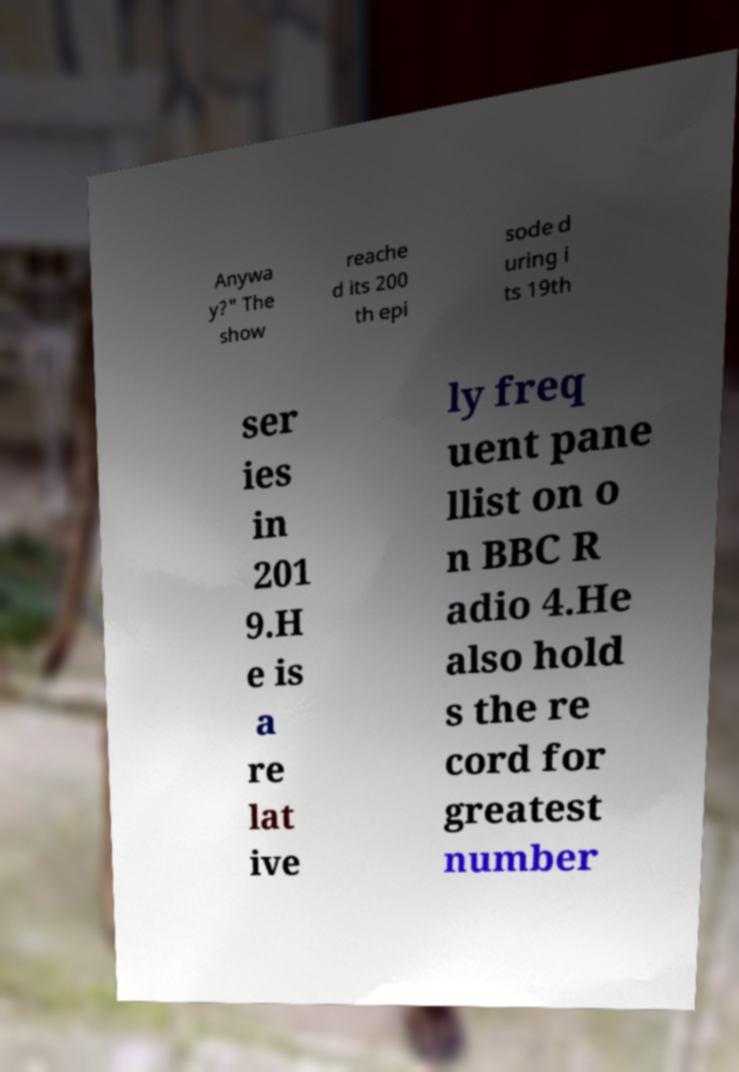Could you extract and type out the text from this image? Anywa y?" The show reache d its 200 th epi sode d uring i ts 19th ser ies in 201 9.H e is a re lat ive ly freq uent pane llist on o n BBC R adio 4.He also hold s the re cord for greatest number 